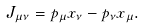<formula> <loc_0><loc_0><loc_500><loc_500>J _ { \mu \nu } = p _ { \mu } x _ { \nu } - p _ { \nu } x _ { \mu } .</formula> 